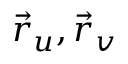Convert formula to latex. <formula><loc_0><loc_0><loc_500><loc_500>{ \vec { r } } _ { u } , { \vec { r } } _ { v }</formula> 